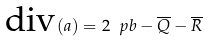<formula> <loc_0><loc_0><loc_500><loc_500>\text {div} ( a ) = 2 \ p b - \overline { Q } - \overline { R }</formula> 